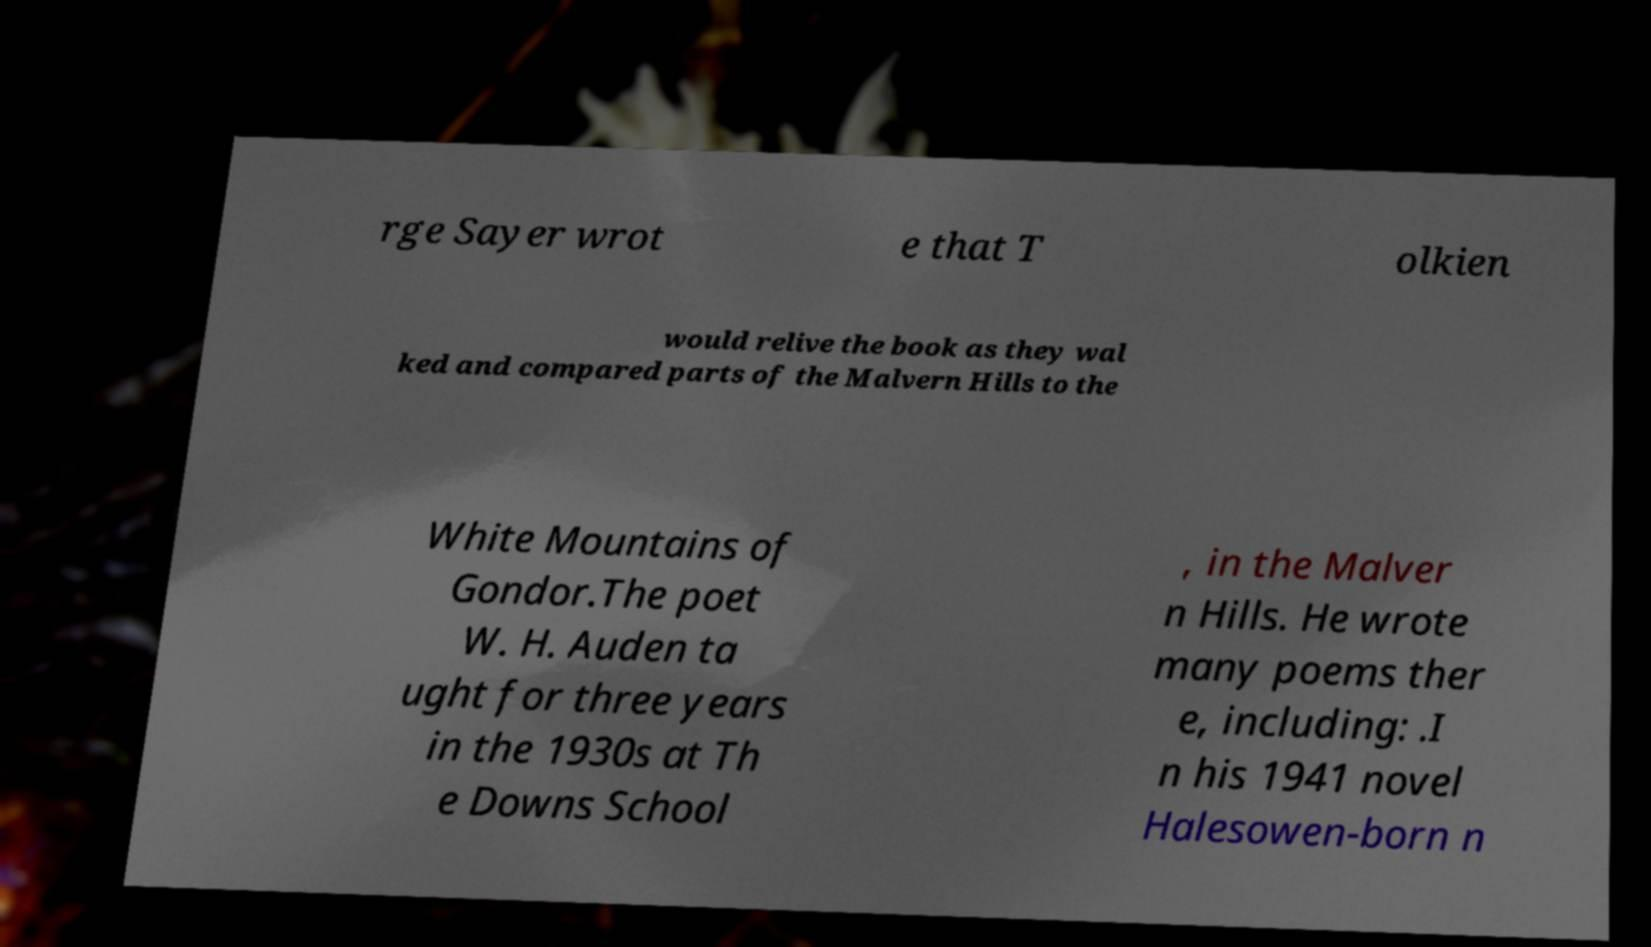There's text embedded in this image that I need extracted. Can you transcribe it verbatim? rge Sayer wrot e that T olkien would relive the book as they wal ked and compared parts of the Malvern Hills to the White Mountains of Gondor.The poet W. H. Auden ta ught for three years in the 1930s at Th e Downs School , in the Malver n Hills. He wrote many poems ther e, including: .I n his 1941 novel Halesowen-born n 